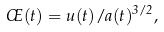<formula> <loc_0><loc_0><loc_500><loc_500>\phi ( t ) = u ( t ) / a ( t ) ^ { 3 / 2 } ,</formula> 